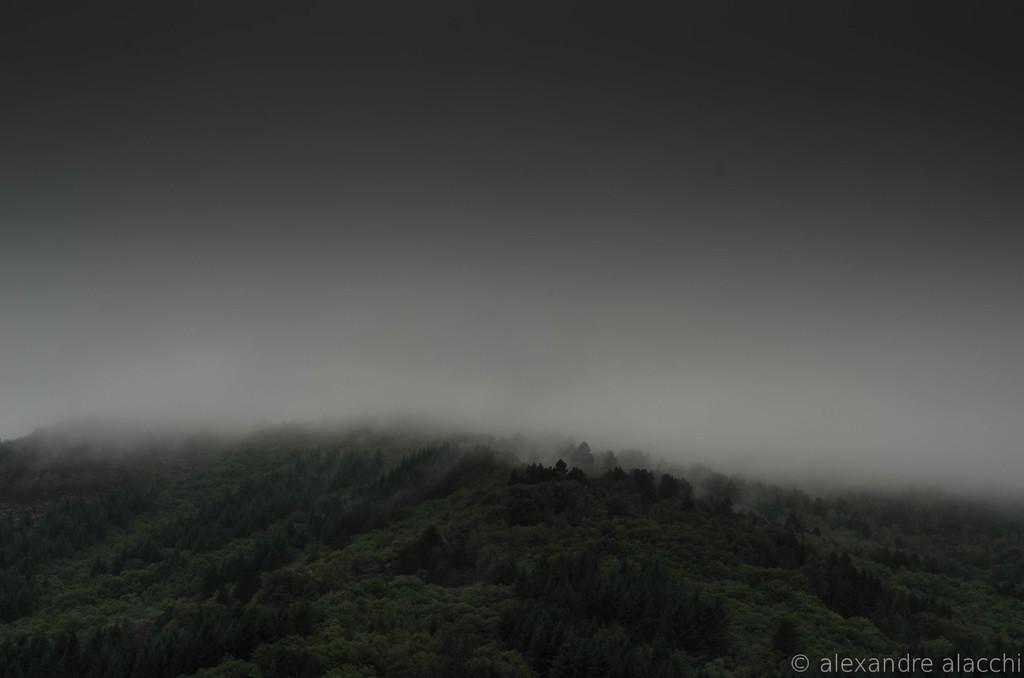How would you summarize this image in a sentence or two? At the bottom of the picture, we see the trees. In the background, we see the sky. In the background, it is covered with the fog. 